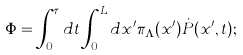<formula> <loc_0><loc_0><loc_500><loc_500>\Phi = \int _ { 0 } ^ { \tau } d t \int _ { 0 } ^ { L } d x ^ { \prime } \pi _ { \mathbf \Lambda } ( x ^ { \prime } ) \dot { P } ( x ^ { \prime } , t ) ;</formula> 